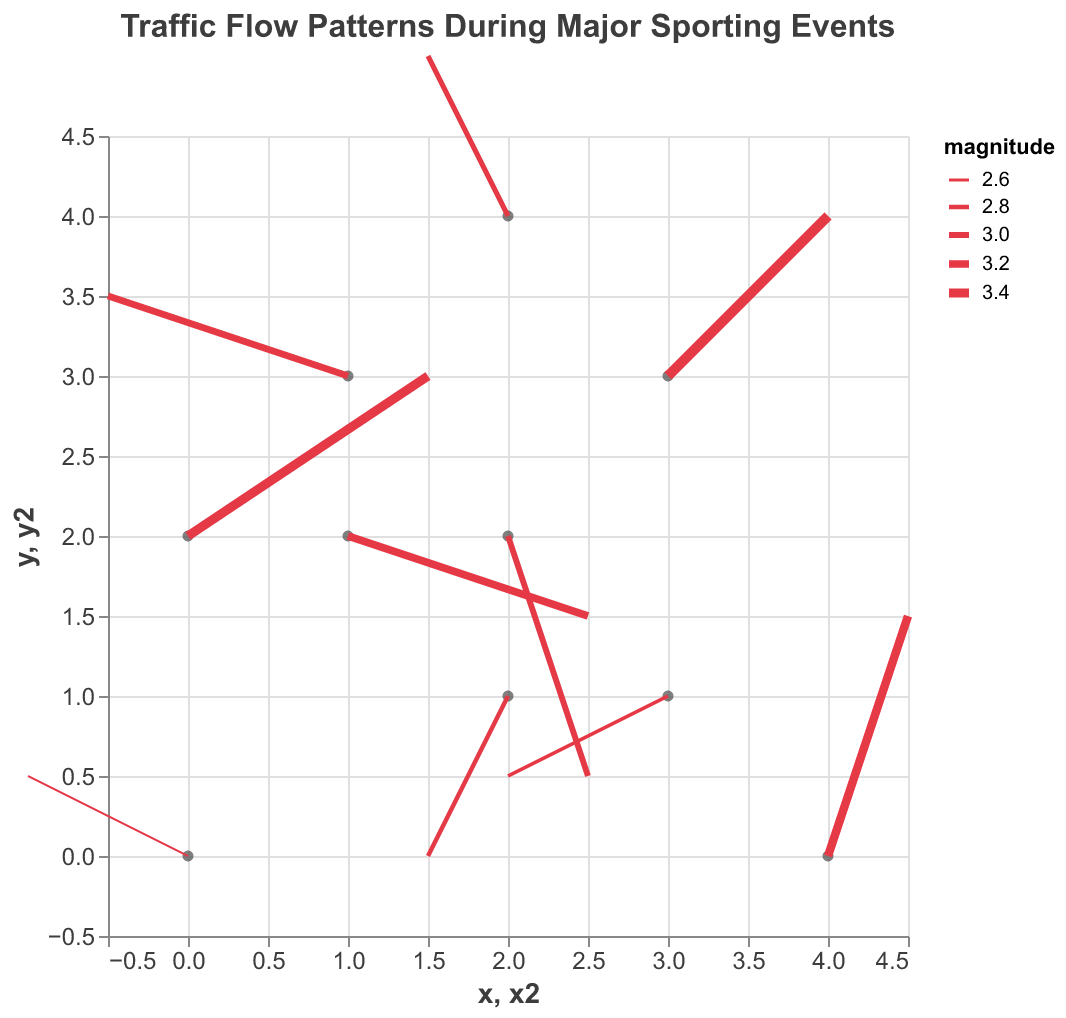How many distinct data points are represented in the plot? Count the number of arrows (or vectors) present in the plot. Each arrow represents one data point.
Answer: 10 What is the title of the figure? Identify the text displayed as the title at the top of the figure.
Answer: Traffic Flow Patterns During Major Sporting Events Which data point has the highest magnitude of traffic flow? Look for the vector with the thickest arrow, as the stroke width is proportional to the magnitude. The vector at (3,3) appears to be the thickest.
Answer: (3, 3) What is the general direction of traffic flow at (0,2)? Identify the starting point and follow the direction of the arrow. At (0,2), the arrow points to the right and slightly up.
Answer: Right and up Compare the traffic flow direction at (1,2) and (2,2). Which direction is more vertical? Analyze the arrows at both points and determine their orientations. The arrow at (2,2) points mainly downwards, which is more vertical compared to the more horizontal arrow at (1,2).
Answer: (2, 2) How many data points show a leftward traffic flow? Count the number of vectors with a significant negative u-component (x-direction). The points at (0,0), (2,1), (1,3), (3,1), and (2,4) show leftward flow.
Answer: 5 What is the average magnitude of traffic flow at coordinates where y is 2? Identify the magnitudes at (1,2), (2,2), and (0,2). The magnitudes are 3.2, 3.0, and 3.4. Calculate the average: (3.2 + 3.0 + 3.4) / 3 = 3.2
Answer: 3.2 Which direction does the traffic flow at (4,0) point to? Observe the arrow starting at (4,0) and identify its direction. It points upwards and slightly to the right.
Answer: Up and right What is the difference in magnitude between the vectors at (0,0) and (0,2)? Find the magnitudes of the vectors at (0,0) and (0,2) and subtract them: 3.4 - 2.5 = 0.9.
Answer: 0.9 Which vector has a downward traffic flow and is closest to the origin (0,0)? Identify the vectors pointing downwards and find the one with the smallest distance from (0,0). The vector at (2,1) points downwards and is the closest.
Answer: (2, 1) 